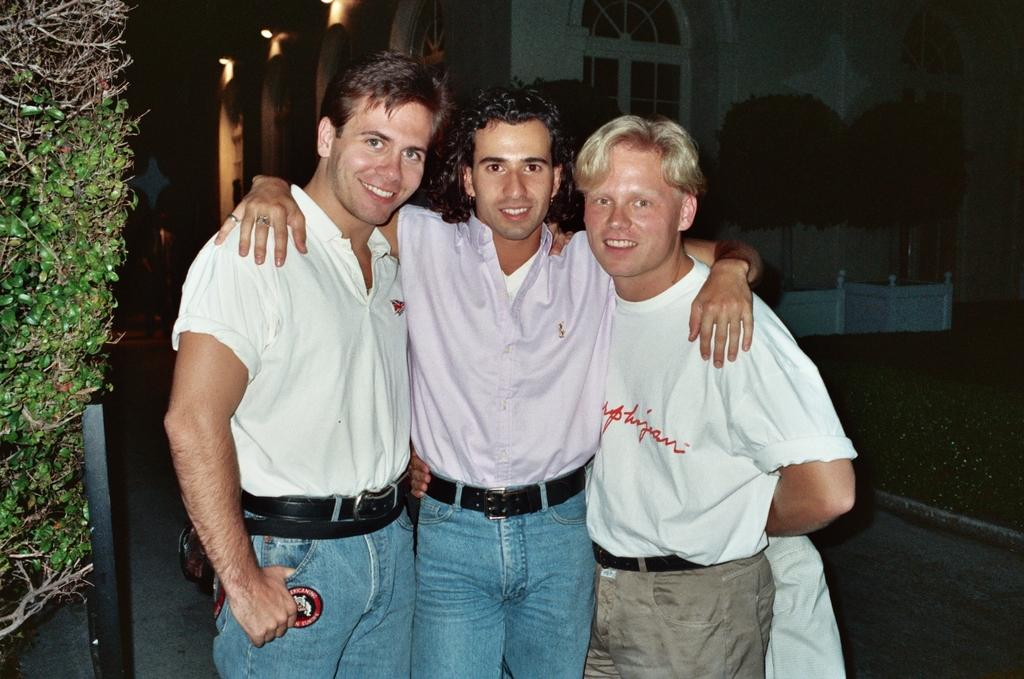What is happening in the center of the image? There are men standing in the center of the image. What surface are the men standing on? The men are standing on the floor. What can be seen on the left side of the image? There is a tree and a pole on the left side of the image. What is visible in the background of the image? There is a building and trees in the background of the image. How many jellyfish are swimming in the background of the image? There are no jellyfish present in the image; it features a building and trees in the background. What is the fifth object in the image? The provided facts do not mention a fifth object in the image. 